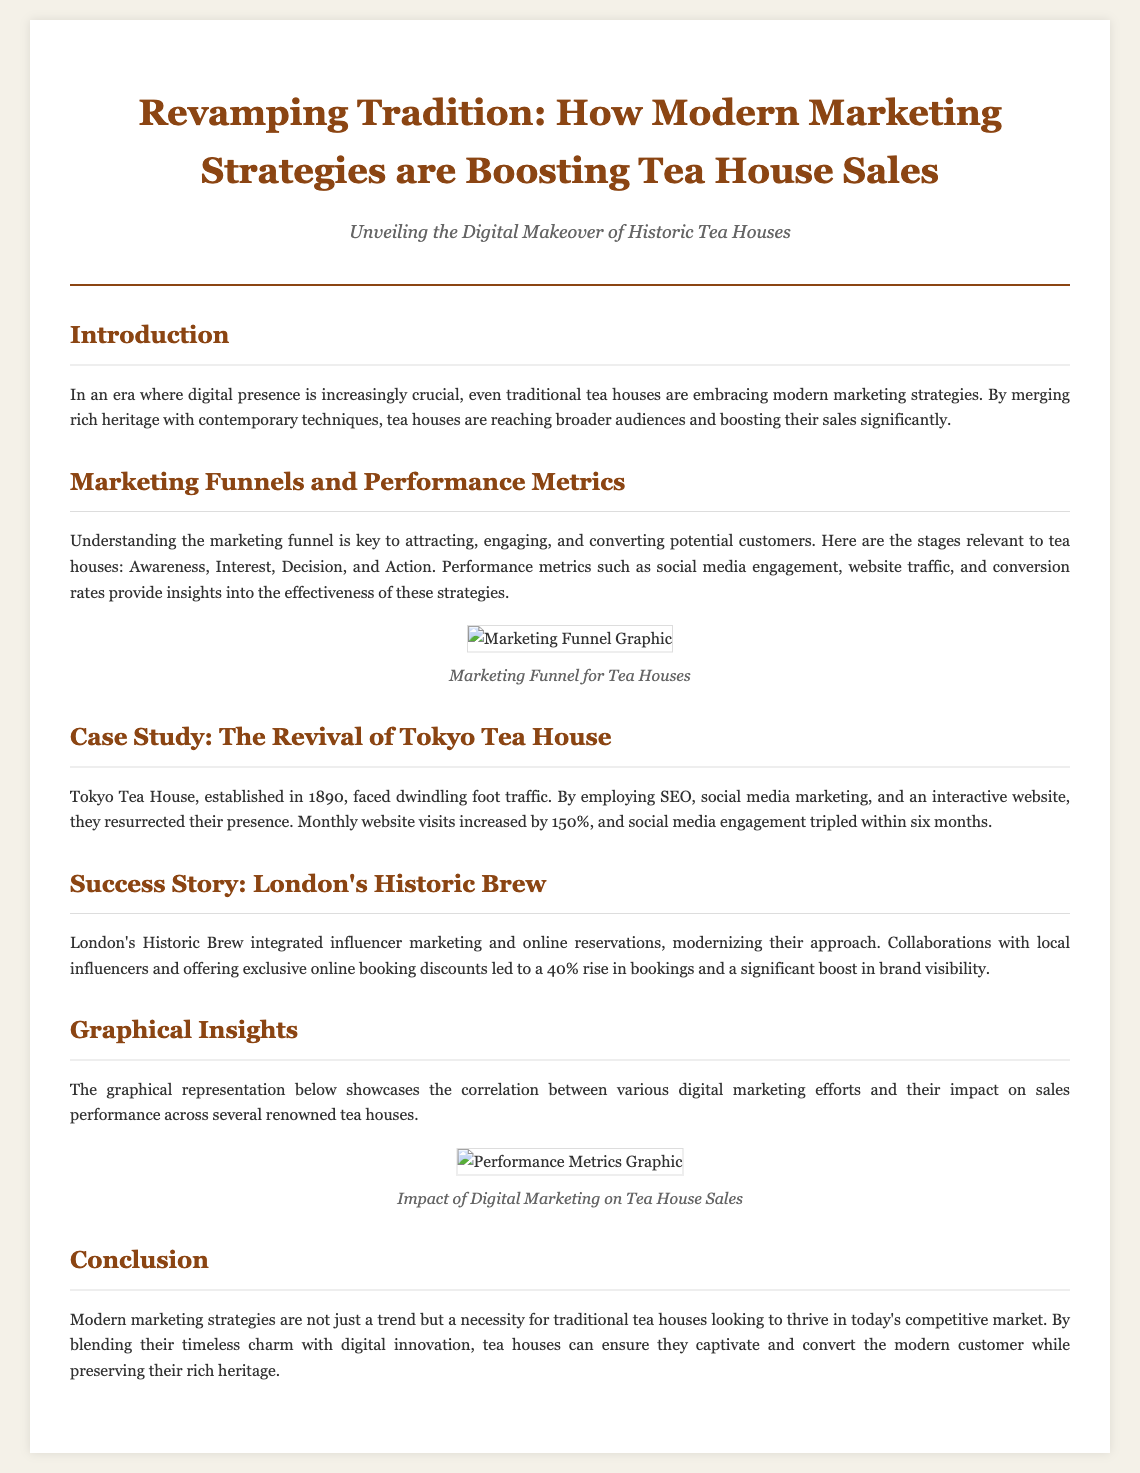What is the title of the article? The title is presented prominently at the top of the document, indicating the main focus of the piece.
Answer: Revamping Tradition: How Modern Marketing Strategies are Boosting Tea House Sales What year was the Tokyo Tea House established? The establishment year is mentioned in the context of the case study for Tokyo Tea House.
Answer: 1890 What percentage did monthly website visits increase for Tokyo Tea House? This statistic is provided in the success story of Tokyo Tea House, showcasing the effectiveness of their digital strategies.
Answer: 150% What type of marketing did London's Historic Brew integrate? The document specifically mentions the type of marketing strategy implemented by London's Historic Brew in their success story.
Answer: Influencer marketing What are the four stages of the marketing funnel relevant to tea houses? The stages are outlined in the section discussing marketing funnels, detailing the process of customer engagement.
Answer: Awareness, Interest, Decision, Action What is the main visual focus of the "Graphical Insights" section? This section describes a graphical representation that illustrates the relationship between digital marketing efforts and sales performance.
Answer: Correlation between various digital marketing efforts and their impact on sales performance What is the conclusion drawn regarding modern marketing strategies? The conclusion summarizes the article's message about the necessity of modern approaches for traditional tea houses.
Answer: A necessity for traditional tea houses looking to thrive in today's competitive market 